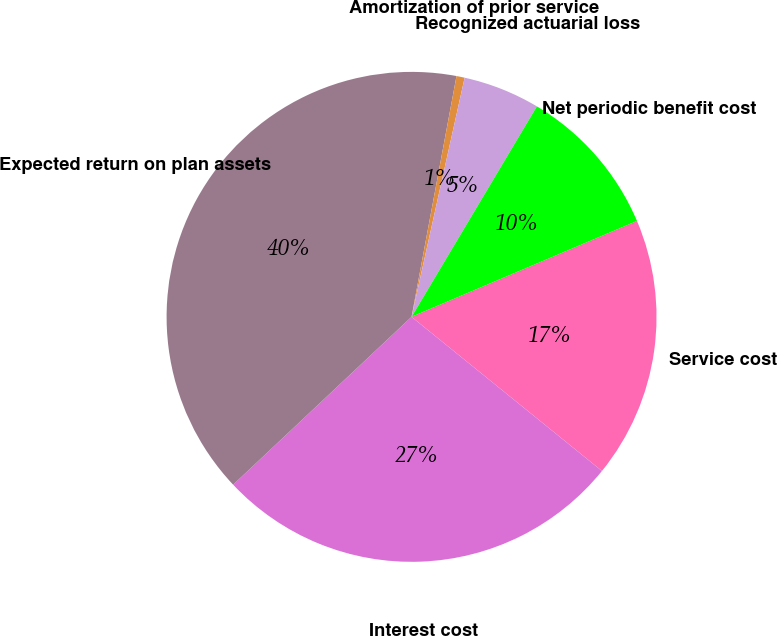Convert chart to OTSL. <chart><loc_0><loc_0><loc_500><loc_500><pie_chart><fcel>Service cost<fcel>Interest cost<fcel>Expected return on plan assets<fcel>Amortization of prior service<fcel>Recognized actuarial loss<fcel>Net periodic benefit cost<nl><fcel>17.23%<fcel>27.15%<fcel>39.95%<fcel>0.54%<fcel>5.07%<fcel>10.05%<nl></chart> 